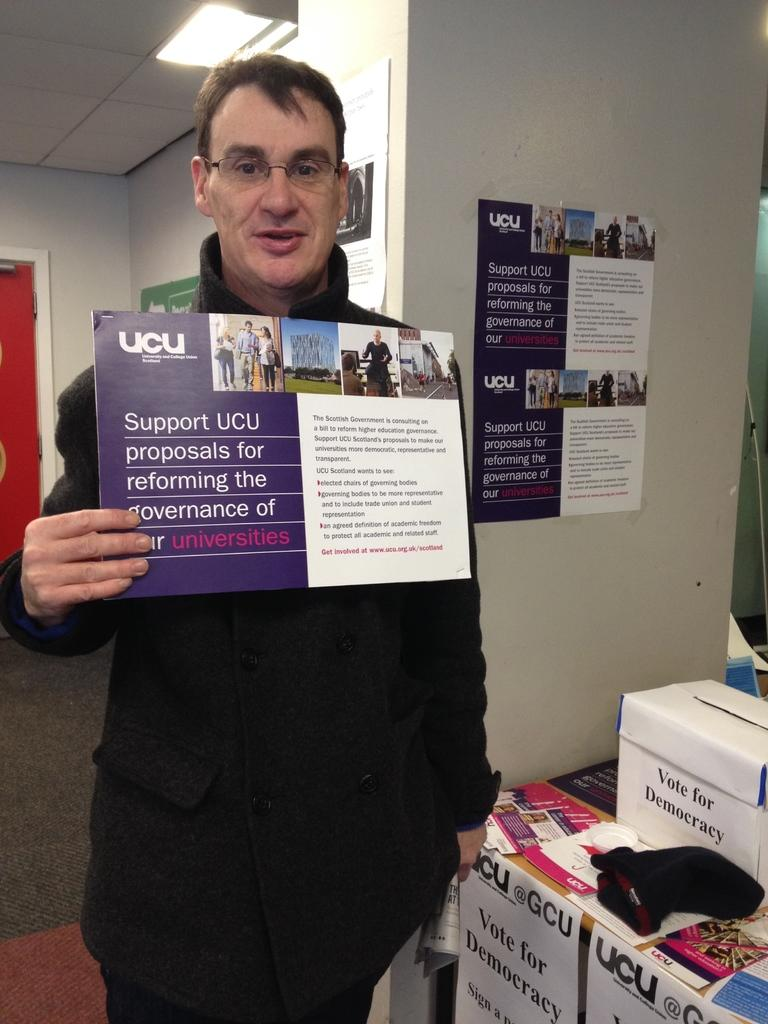<image>
Provide a brief description of the given image. A man is holding up a brochure that has UCU on the top left side. 